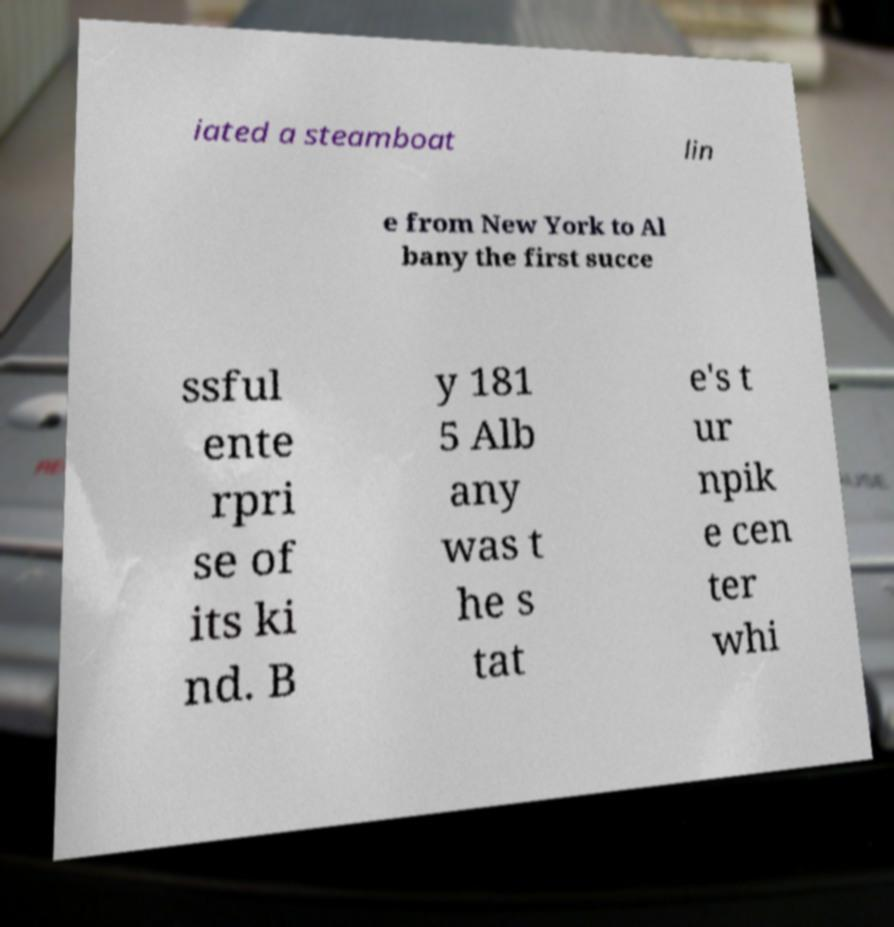Could you extract and type out the text from this image? iated a steamboat lin e from New York to Al bany the first succe ssful ente rpri se of its ki nd. B y 181 5 Alb any was t he s tat e's t ur npik e cen ter whi 